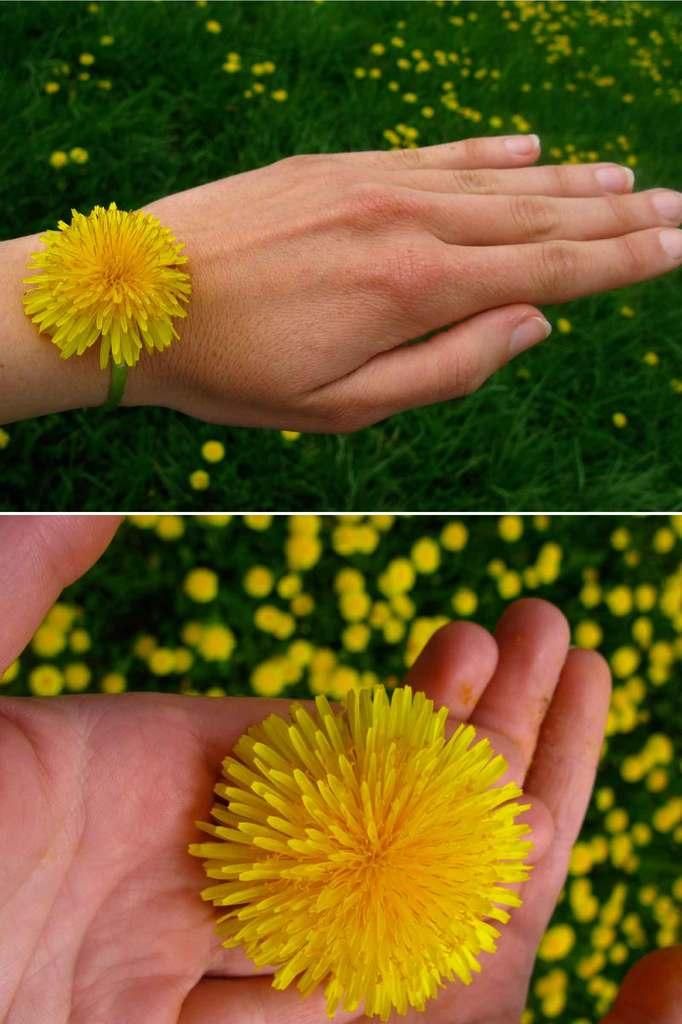What is the main subject of the image? The main subject of the image is a flower. How is the flower being held in the image? The flower is held in someone's hand in the image. Is there any other way the flower is connected to someone in the image? Yes, the flower is tied to someone's hand in another part of the image. What can be seen in the background of the image? There are plants with flowers in the background of the image. What type of stamp can be seen on the flower in the image? There is no stamp present on the flower in the image. What kind of error is visible on the flower in the image? There is no error visible on the flower in the image. 